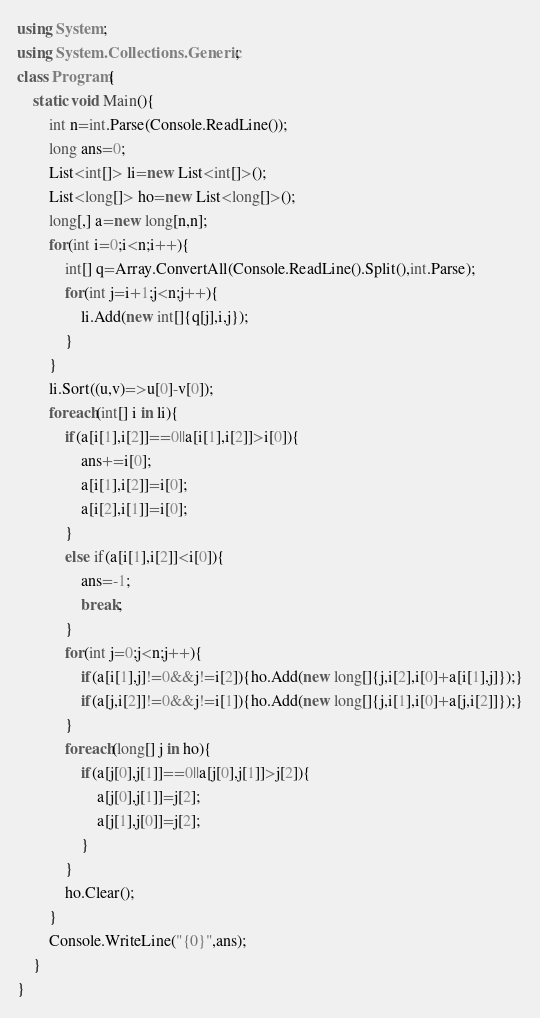<code> <loc_0><loc_0><loc_500><loc_500><_C#_>using System;
using System.Collections.Generic;
class Program{
	static void Main(){
		int n=int.Parse(Console.ReadLine());
		long ans=0;
		List<int[]> li=new List<int[]>();
		List<long[]> ho=new List<long[]>();
		long[,] a=new long[n,n];
		for(int i=0;i<n;i++){
			int[] q=Array.ConvertAll(Console.ReadLine().Split(),int.Parse);
			for(int j=i+1;j<n;j++){
				li.Add(new int[]{q[j],i,j});
			}
		}
		li.Sort((u,v)=>u[0]-v[0]);
		foreach(int[] i in li){
			if(a[i[1],i[2]]==0||a[i[1],i[2]]>i[0]){
				ans+=i[0];
				a[i[1],i[2]]=i[0];
				a[i[2],i[1]]=i[0];
			}
			else if(a[i[1],i[2]]<i[0]){
				ans=-1;
				break;
			}
			for(int j=0;j<n;j++){
				if(a[i[1],j]!=0&&j!=i[2]){ho.Add(new long[]{j,i[2],i[0]+a[i[1],j]});}
				if(a[j,i[2]]!=0&&j!=i[1]){ho.Add(new long[]{j,i[1],i[0]+a[j,i[2]]});}
			}
			foreach(long[] j in ho){
				if(a[j[0],j[1]]==0||a[j[0],j[1]]>j[2]){
					a[j[0],j[1]]=j[2];
					a[j[1],j[0]]=j[2];
				}
			}
			ho.Clear();
		}
		Console.WriteLine("{0}",ans);
	}
}</code> 